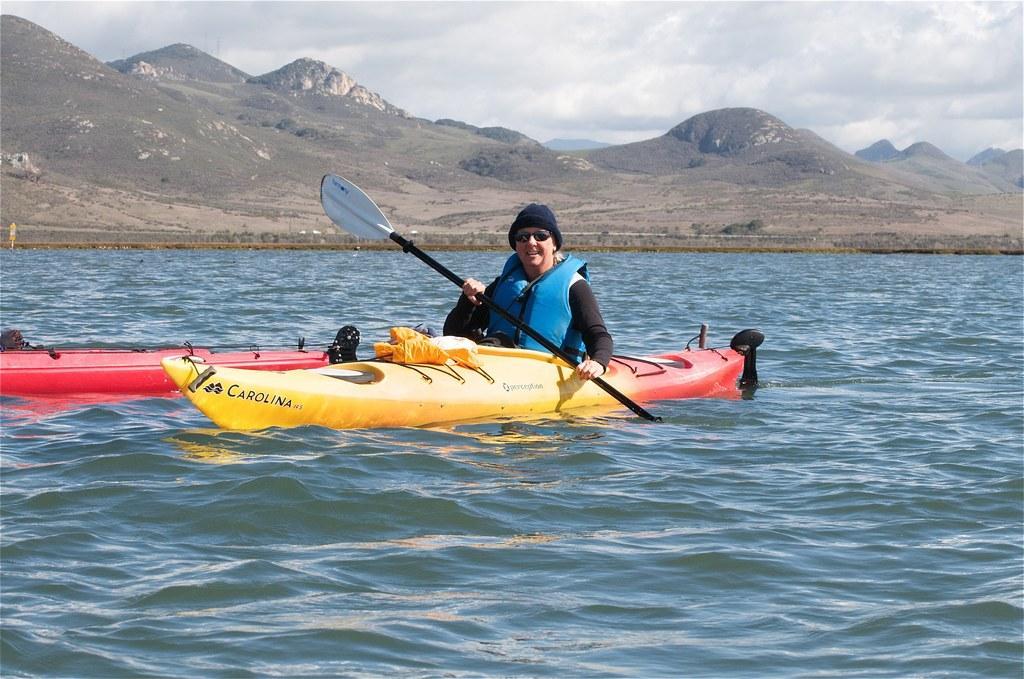Can you describe this image briefly? In this image in the center there are boats and there is a person sitting in the boat and rowing and having smile on the face. In the background there are mountains and the sky is cloudy. 